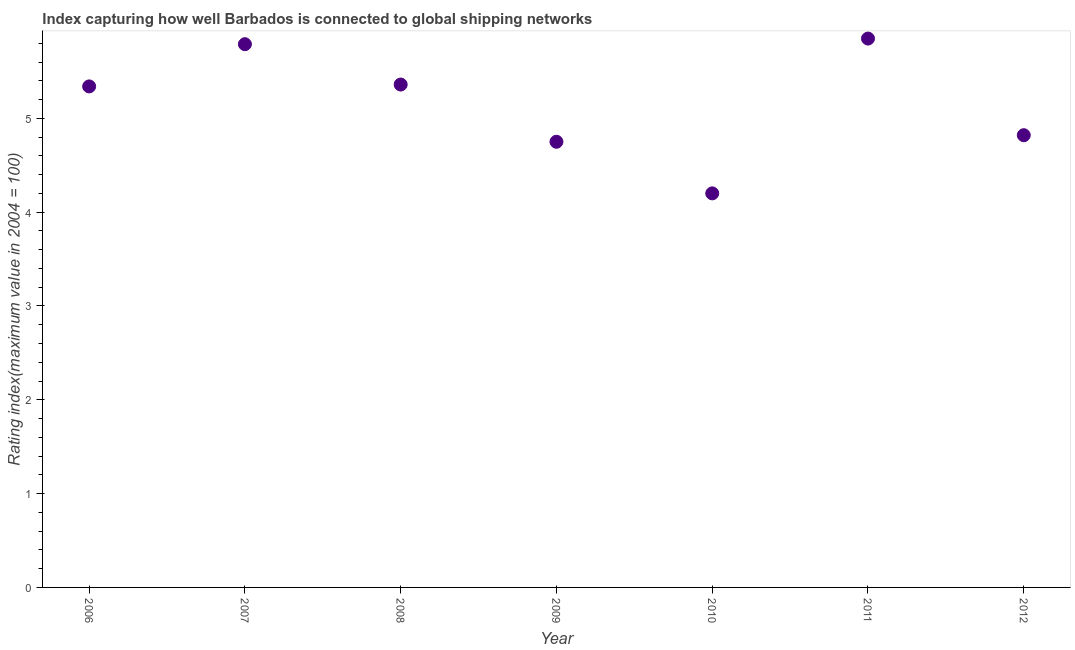What is the liner shipping connectivity index in 2012?
Your answer should be very brief. 4.82. Across all years, what is the maximum liner shipping connectivity index?
Make the answer very short. 5.85. In which year was the liner shipping connectivity index maximum?
Provide a succinct answer. 2011. What is the sum of the liner shipping connectivity index?
Keep it short and to the point. 36.11. What is the difference between the liner shipping connectivity index in 2010 and 2011?
Your response must be concise. -1.65. What is the average liner shipping connectivity index per year?
Provide a succinct answer. 5.16. What is the median liner shipping connectivity index?
Offer a terse response. 5.34. Do a majority of the years between 2006 and 2012 (inclusive) have liner shipping connectivity index greater than 3.4 ?
Offer a very short reply. Yes. What is the ratio of the liner shipping connectivity index in 2007 to that in 2012?
Give a very brief answer. 1.2. Is the difference between the liner shipping connectivity index in 2007 and 2010 greater than the difference between any two years?
Provide a short and direct response. No. What is the difference between the highest and the second highest liner shipping connectivity index?
Ensure brevity in your answer.  0.06. What is the difference between the highest and the lowest liner shipping connectivity index?
Ensure brevity in your answer.  1.65. In how many years, is the liner shipping connectivity index greater than the average liner shipping connectivity index taken over all years?
Keep it short and to the point. 4. How many dotlines are there?
Ensure brevity in your answer.  1. Does the graph contain any zero values?
Give a very brief answer. No. Does the graph contain grids?
Offer a very short reply. No. What is the title of the graph?
Make the answer very short. Index capturing how well Barbados is connected to global shipping networks. What is the label or title of the X-axis?
Provide a succinct answer. Year. What is the label or title of the Y-axis?
Provide a short and direct response. Rating index(maximum value in 2004 = 100). What is the Rating index(maximum value in 2004 = 100) in 2006?
Offer a very short reply. 5.34. What is the Rating index(maximum value in 2004 = 100) in 2007?
Offer a terse response. 5.79. What is the Rating index(maximum value in 2004 = 100) in 2008?
Provide a succinct answer. 5.36. What is the Rating index(maximum value in 2004 = 100) in 2009?
Make the answer very short. 4.75. What is the Rating index(maximum value in 2004 = 100) in 2011?
Keep it short and to the point. 5.85. What is the Rating index(maximum value in 2004 = 100) in 2012?
Your response must be concise. 4.82. What is the difference between the Rating index(maximum value in 2004 = 100) in 2006 and 2007?
Offer a terse response. -0.45. What is the difference between the Rating index(maximum value in 2004 = 100) in 2006 and 2008?
Ensure brevity in your answer.  -0.02. What is the difference between the Rating index(maximum value in 2004 = 100) in 2006 and 2009?
Keep it short and to the point. 0.59. What is the difference between the Rating index(maximum value in 2004 = 100) in 2006 and 2010?
Your answer should be very brief. 1.14. What is the difference between the Rating index(maximum value in 2004 = 100) in 2006 and 2011?
Provide a short and direct response. -0.51. What is the difference between the Rating index(maximum value in 2004 = 100) in 2006 and 2012?
Make the answer very short. 0.52. What is the difference between the Rating index(maximum value in 2004 = 100) in 2007 and 2008?
Provide a short and direct response. 0.43. What is the difference between the Rating index(maximum value in 2004 = 100) in 2007 and 2009?
Your answer should be compact. 1.04. What is the difference between the Rating index(maximum value in 2004 = 100) in 2007 and 2010?
Your answer should be compact. 1.59. What is the difference between the Rating index(maximum value in 2004 = 100) in 2007 and 2011?
Provide a succinct answer. -0.06. What is the difference between the Rating index(maximum value in 2004 = 100) in 2007 and 2012?
Offer a terse response. 0.97. What is the difference between the Rating index(maximum value in 2004 = 100) in 2008 and 2009?
Offer a very short reply. 0.61. What is the difference between the Rating index(maximum value in 2004 = 100) in 2008 and 2010?
Offer a terse response. 1.16. What is the difference between the Rating index(maximum value in 2004 = 100) in 2008 and 2011?
Make the answer very short. -0.49. What is the difference between the Rating index(maximum value in 2004 = 100) in 2008 and 2012?
Offer a terse response. 0.54. What is the difference between the Rating index(maximum value in 2004 = 100) in 2009 and 2010?
Provide a succinct answer. 0.55. What is the difference between the Rating index(maximum value in 2004 = 100) in 2009 and 2012?
Your answer should be very brief. -0.07. What is the difference between the Rating index(maximum value in 2004 = 100) in 2010 and 2011?
Ensure brevity in your answer.  -1.65. What is the difference between the Rating index(maximum value in 2004 = 100) in 2010 and 2012?
Your answer should be very brief. -0.62. What is the difference between the Rating index(maximum value in 2004 = 100) in 2011 and 2012?
Keep it short and to the point. 1.03. What is the ratio of the Rating index(maximum value in 2004 = 100) in 2006 to that in 2007?
Keep it short and to the point. 0.92. What is the ratio of the Rating index(maximum value in 2004 = 100) in 2006 to that in 2008?
Offer a very short reply. 1. What is the ratio of the Rating index(maximum value in 2004 = 100) in 2006 to that in 2009?
Provide a short and direct response. 1.12. What is the ratio of the Rating index(maximum value in 2004 = 100) in 2006 to that in 2010?
Keep it short and to the point. 1.27. What is the ratio of the Rating index(maximum value in 2004 = 100) in 2006 to that in 2012?
Give a very brief answer. 1.11. What is the ratio of the Rating index(maximum value in 2004 = 100) in 2007 to that in 2009?
Make the answer very short. 1.22. What is the ratio of the Rating index(maximum value in 2004 = 100) in 2007 to that in 2010?
Give a very brief answer. 1.38. What is the ratio of the Rating index(maximum value in 2004 = 100) in 2007 to that in 2012?
Keep it short and to the point. 1.2. What is the ratio of the Rating index(maximum value in 2004 = 100) in 2008 to that in 2009?
Keep it short and to the point. 1.13. What is the ratio of the Rating index(maximum value in 2004 = 100) in 2008 to that in 2010?
Give a very brief answer. 1.28. What is the ratio of the Rating index(maximum value in 2004 = 100) in 2008 to that in 2011?
Provide a succinct answer. 0.92. What is the ratio of the Rating index(maximum value in 2004 = 100) in 2008 to that in 2012?
Keep it short and to the point. 1.11. What is the ratio of the Rating index(maximum value in 2004 = 100) in 2009 to that in 2010?
Provide a succinct answer. 1.13. What is the ratio of the Rating index(maximum value in 2004 = 100) in 2009 to that in 2011?
Provide a succinct answer. 0.81. What is the ratio of the Rating index(maximum value in 2004 = 100) in 2010 to that in 2011?
Provide a short and direct response. 0.72. What is the ratio of the Rating index(maximum value in 2004 = 100) in 2010 to that in 2012?
Provide a succinct answer. 0.87. What is the ratio of the Rating index(maximum value in 2004 = 100) in 2011 to that in 2012?
Give a very brief answer. 1.21. 